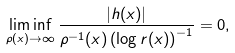<formula> <loc_0><loc_0><loc_500><loc_500>\liminf _ { \rho ( x ) \to \infty } \frac { | h ( x ) | } { \rho ^ { - 1 } ( x ) \left ( \log r ( x ) \right ) ^ { - 1 } } = 0 ,</formula> 